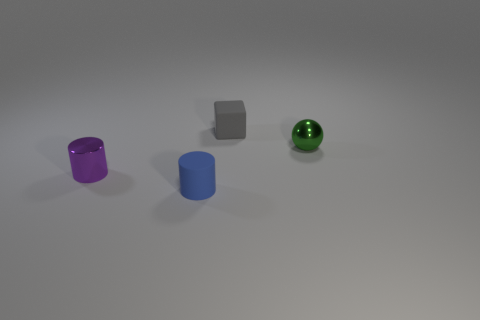Add 1 small gray cubes. How many objects exist? 5 Subtract all balls. How many objects are left? 3 Subtract all small cylinders. Subtract all purple objects. How many objects are left? 1 Add 3 matte cylinders. How many matte cylinders are left? 4 Add 2 green metal balls. How many green metal balls exist? 3 Subtract 1 gray cubes. How many objects are left? 3 